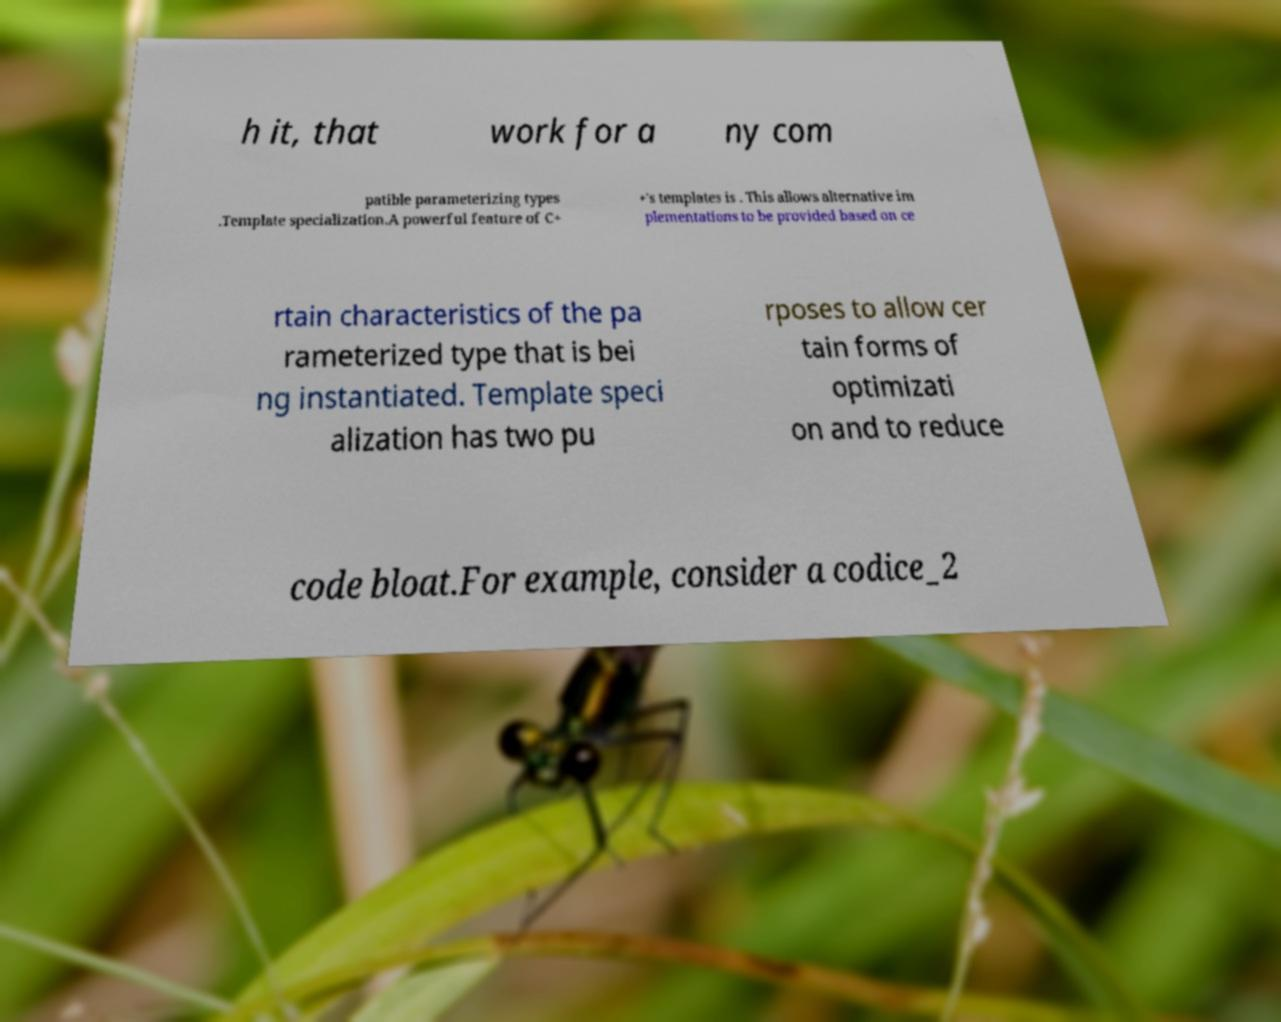Please identify and transcribe the text found in this image. h it, that work for a ny com patible parameterizing types .Template specialization.A powerful feature of C+ +'s templates is . This allows alternative im plementations to be provided based on ce rtain characteristics of the pa rameterized type that is bei ng instantiated. Template speci alization has two pu rposes to allow cer tain forms of optimizati on and to reduce code bloat.For example, consider a codice_2 